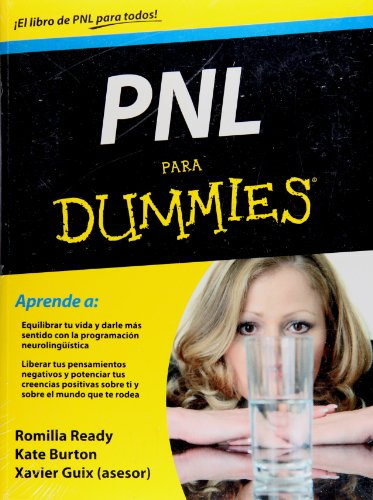What is the title of this book? The title of this book is 'PNL para Dummies (Spanish Edition)', suggesting that it's a practical guide on neurolinguistic programming for Spanish-speaking beginners. 